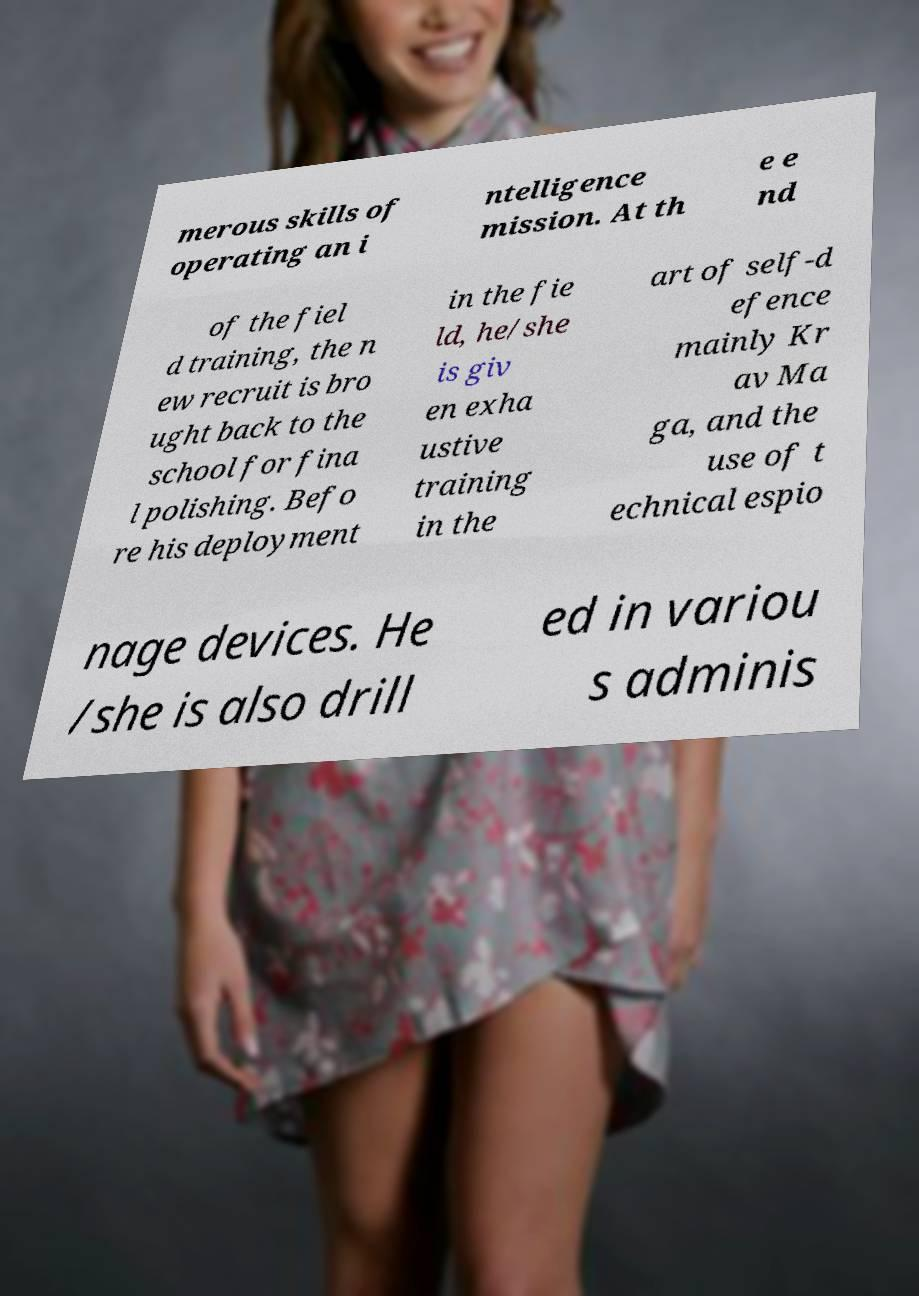I need the written content from this picture converted into text. Can you do that? merous skills of operating an i ntelligence mission. At th e e nd of the fiel d training, the n ew recruit is bro ught back to the school for fina l polishing. Befo re his deployment in the fie ld, he/she is giv en exha ustive training in the art of self-d efence mainly Kr av Ma ga, and the use of t echnical espio nage devices. He /she is also drill ed in variou s adminis 